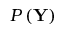<formula> <loc_0><loc_0><loc_500><loc_500>P \left ( Y \right )</formula> 